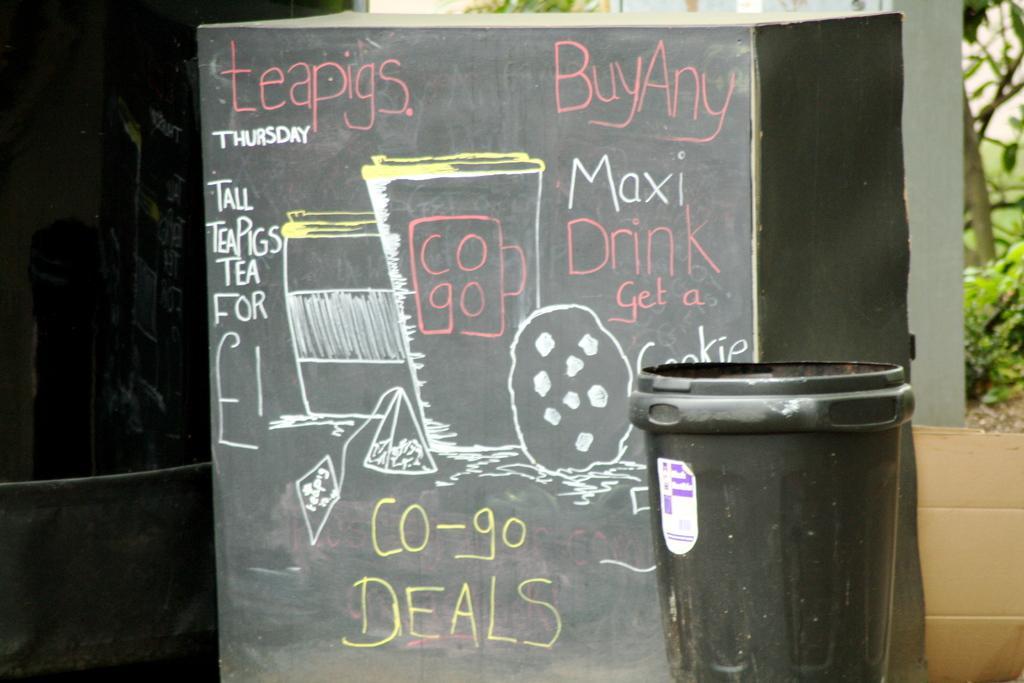Could you give a brief overview of what you see in this image? In this picture there is a board and there is text and there are cups and there is a cookie on the board. In the foreground there is an object. At the back there are trees. On the left side of the image where it looks like a board. At the bottom right there is a cardboard box. 